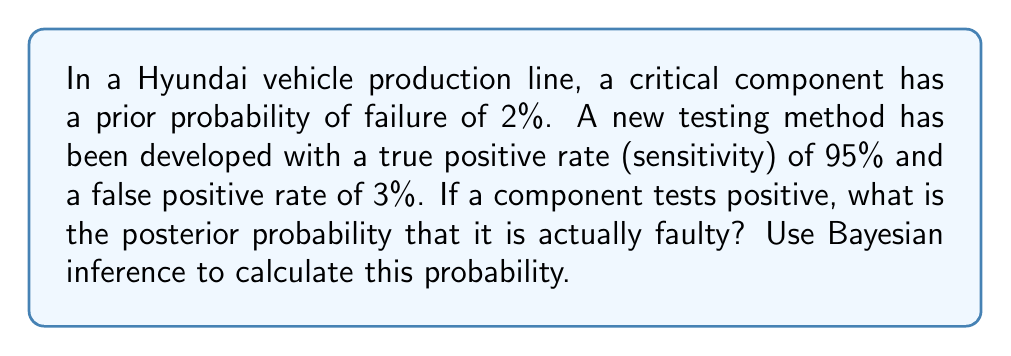Teach me how to tackle this problem. To solve this problem using Bayesian inference, we'll follow these steps:

1. Define the events:
   A: The component is faulty
   B: The test result is positive

2. Given probabilities:
   P(A) = 0.02 (prior probability of failure)
   P(B|A) = 0.95 (true positive rate)
   P(B|not A) = 0.03 (false positive rate)

3. We need to calculate P(A|B) using Bayes' theorem:

   $$P(A|B) = \frac{P(B|A) \cdot P(A)}{P(B)}$$

4. Calculate P(B) using the law of total probability:
   
   $$P(B) = P(B|A) \cdot P(A) + P(B|not A) \cdot P(not A)$$
   $$P(B) = 0.95 \cdot 0.02 + 0.03 \cdot 0.98$$
   $$P(B) = 0.019 + 0.0294 = 0.0484$$

5. Now we can apply Bayes' theorem:

   $$P(A|B) = \frac{0.95 \cdot 0.02}{0.0484}$$
   $$P(A|B) = \frac{0.019}{0.0484} \approx 0.3926$$

6. Convert to percentage:
   0.3926 * 100 ≈ 39.26%
Answer: The posterior probability that a component is actually faulty given a positive test result is approximately 39.26%. 